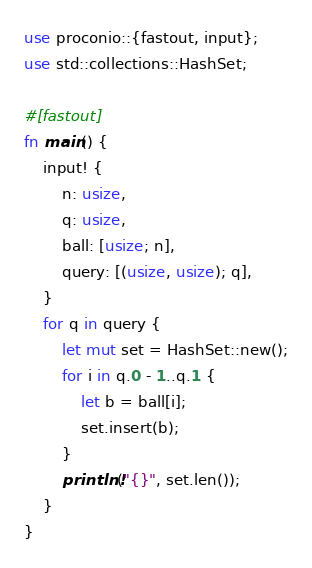Convert code to text. <code><loc_0><loc_0><loc_500><loc_500><_Rust_>use proconio::{fastout, input};
use std::collections::HashSet;

#[fastout]
fn main() {
    input! {
        n: usize,
        q: usize,
        ball: [usize; n],
        query: [(usize, usize); q],
    }
    for q in query {
        let mut set = HashSet::new();
        for i in q.0 - 1..q.1 {
            let b = ball[i];
            set.insert(b);
        }
        println!("{}", set.len());
    }
}
</code> 